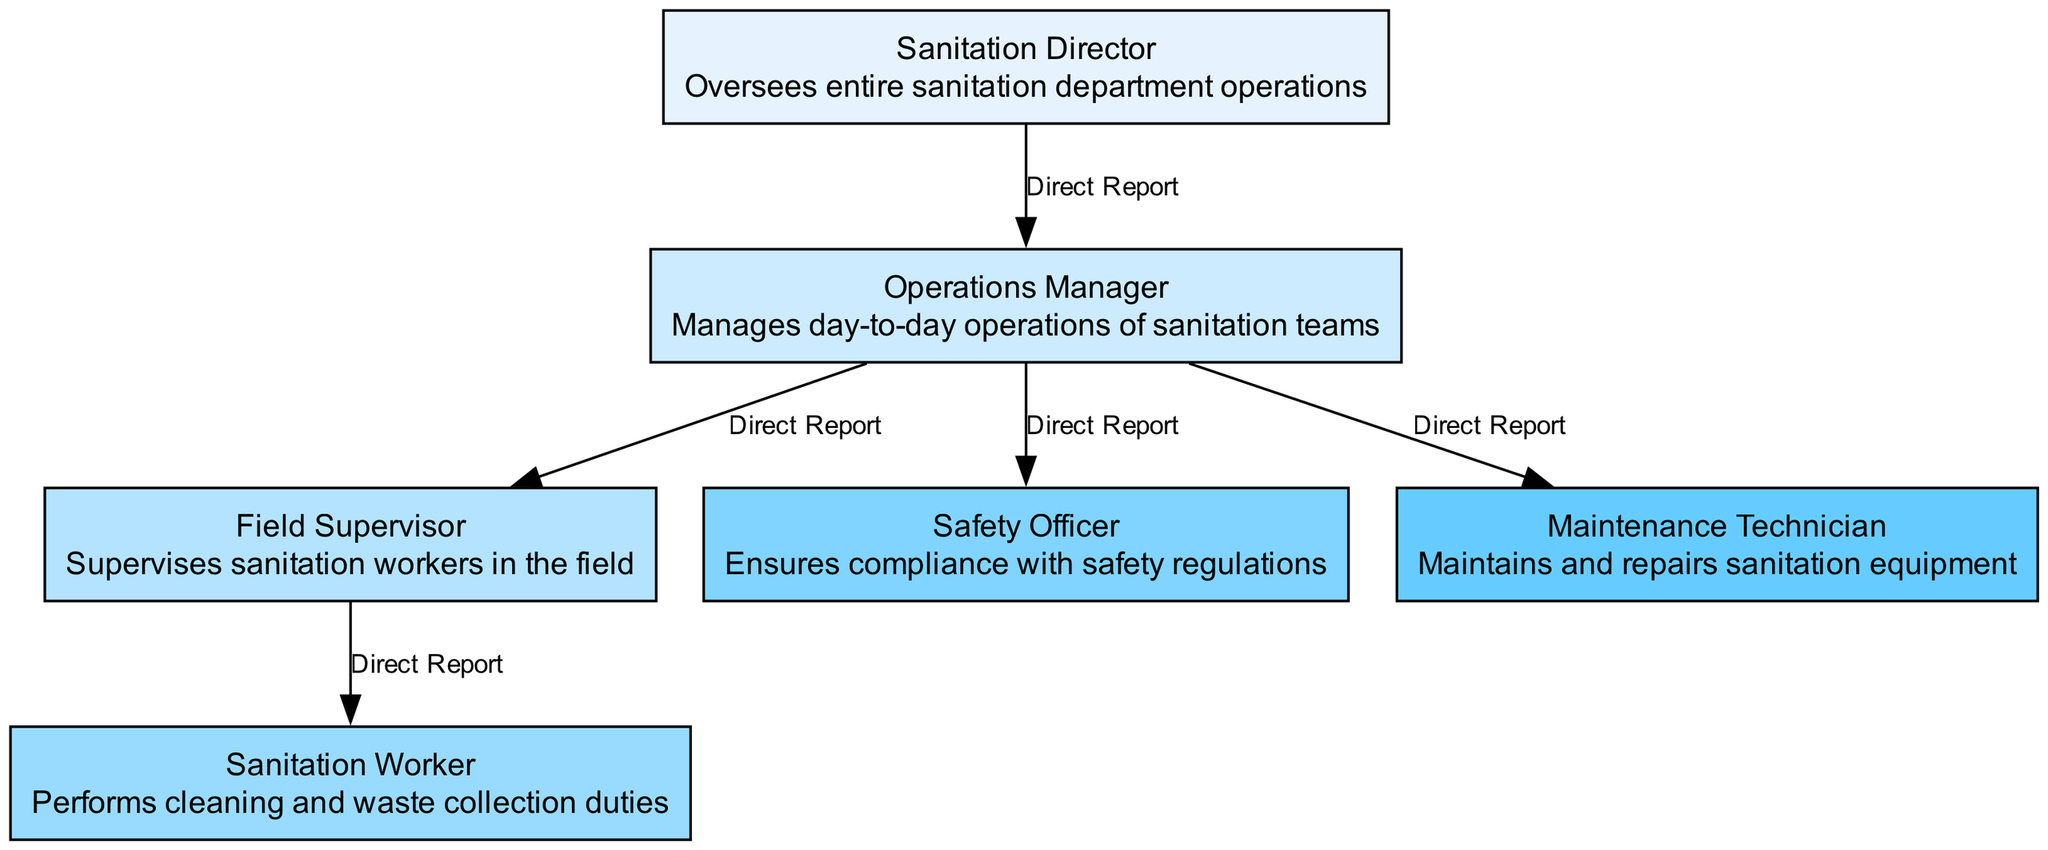What is the top position in the sanitation department? The diagram indicates that the "Sanitation Director" holds the top position as it has no superior node above it.
Answer: Sanitation Director How many direct reports does the Operations Manager have? The diagram shows that the "Operations Manager" has three direct reports: "Field Supervisor," "Safety Officer," and "Maintenance Technician."
Answer: 3 Which role is directly under the Field Supervisor? According to the diagram, the "Sanitation Worker" is the role that directly reports to the "Field Supervisor."
Answer: Sanitation Worker What is the role of the Safety Officer? The diagram specifically states that the "Safety Officer" is responsible for ensuring compliance with safety regulations.
Answer: Ensures compliance with safety regulations What is the relationship between the Sanitation Director and the Operations Manager? The diagram defines the connection between these two nodes as a "Direct Report," indicating that the Operations Manager reports directly to the Sanitation Director.
Answer: Direct Report How many total nodes are represented in the diagram? By counting the nodes listed in the diagram, we find that there are six positions within the organizational structure, including the Sanitation Director and multiple team members.
Answer: 6 Which position manages the sanitation teams daily? The diagram indicates that the "Operations Manager" is responsible for managing the day-to-day operations of the sanitation teams.
Answer: Operations Manager Who supervises the sanitation workers in the field? The role designated in the diagram for this responsibility is the "Field Supervisor."
Answer: Field Supervisor What type of diagram is being used? This visual representation is classified as an "organizational chart," which outlines the hierarchical structure of a department.
Answer: Organizational chart 